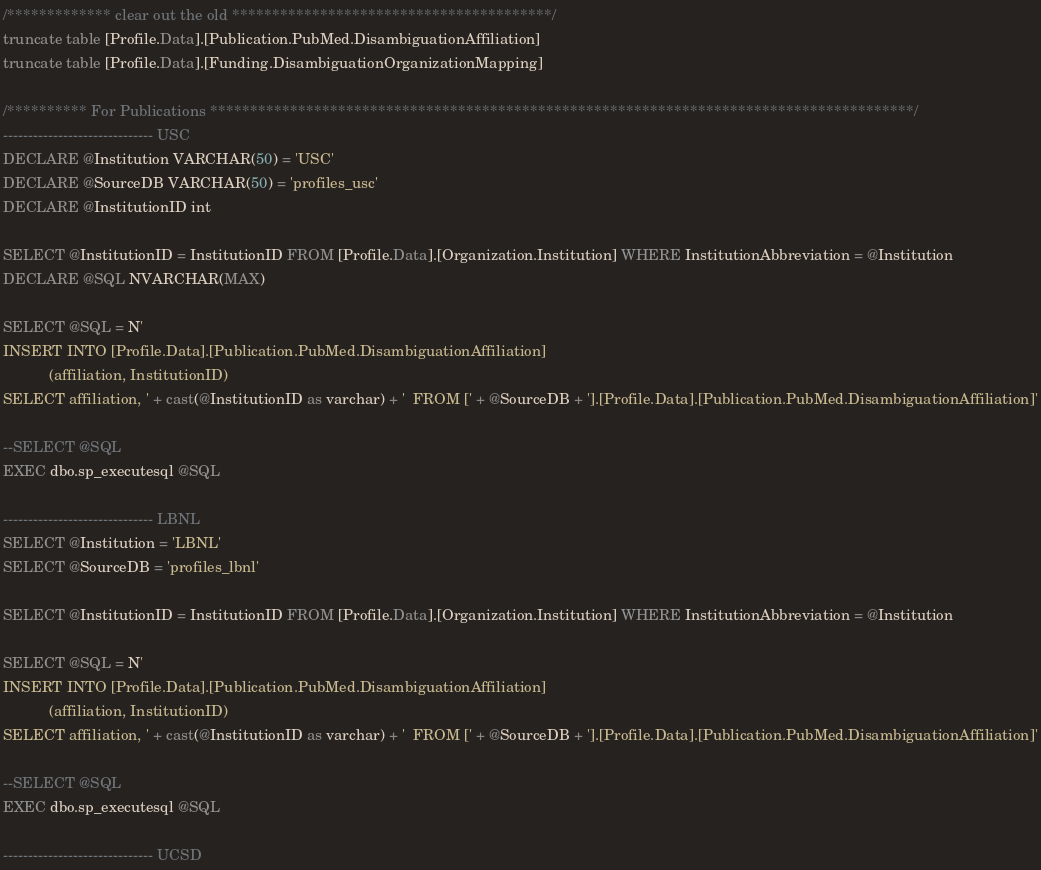<code> <loc_0><loc_0><loc_500><loc_500><_SQL_>
/************* clear out the old ****************************************/
truncate table [Profile.Data].[Publication.PubMed.DisambiguationAffiliation]
truncate table [Profile.Data].[Funding.DisambiguationOrganizationMapping]

/********** For Publications ****************************************************************************************/
------------------------------ USC
DECLARE @Institution VARCHAR(50) = 'USC'
DECLARE @SourceDB VARCHAR(50) = 'profiles_usc' 
DECLARE @InstitutionID int 

SELECT @InstitutionID = InstitutionID FROM [Profile.Data].[Organization.Institution] WHERE InstitutionAbbreviation = @Institution
DECLARE @SQL NVARCHAR(MAX)

SELECT @SQL = N'
INSERT INTO [Profile.Data].[Publication.PubMed.DisambiguationAffiliation]
           (affiliation, InstitutionID)
SELECT affiliation, ' + cast(@InstitutionID as varchar) + '  FROM [' + @SourceDB + '].[Profile.Data].[Publication.PubMed.DisambiguationAffiliation]'

--SELECT @SQL
EXEC dbo.sp_executesql @SQL

------------------------------ LBNL
SELECT @Institution = 'LBNL'
SELECT @SourceDB = 'profiles_lbnl' 

SELECT @InstitutionID = InstitutionID FROM [Profile.Data].[Organization.Institution] WHERE InstitutionAbbreviation = @Institution

SELECT @SQL = N'
INSERT INTO [Profile.Data].[Publication.PubMed.DisambiguationAffiliation]
           (affiliation, InstitutionID)
SELECT affiliation, ' + cast(@InstitutionID as varchar) + '  FROM [' + @SourceDB + '].[Profile.Data].[Publication.PubMed.DisambiguationAffiliation]'

--SELECT @SQL
EXEC dbo.sp_executesql @SQL 

------------------------------ UCSD</code> 